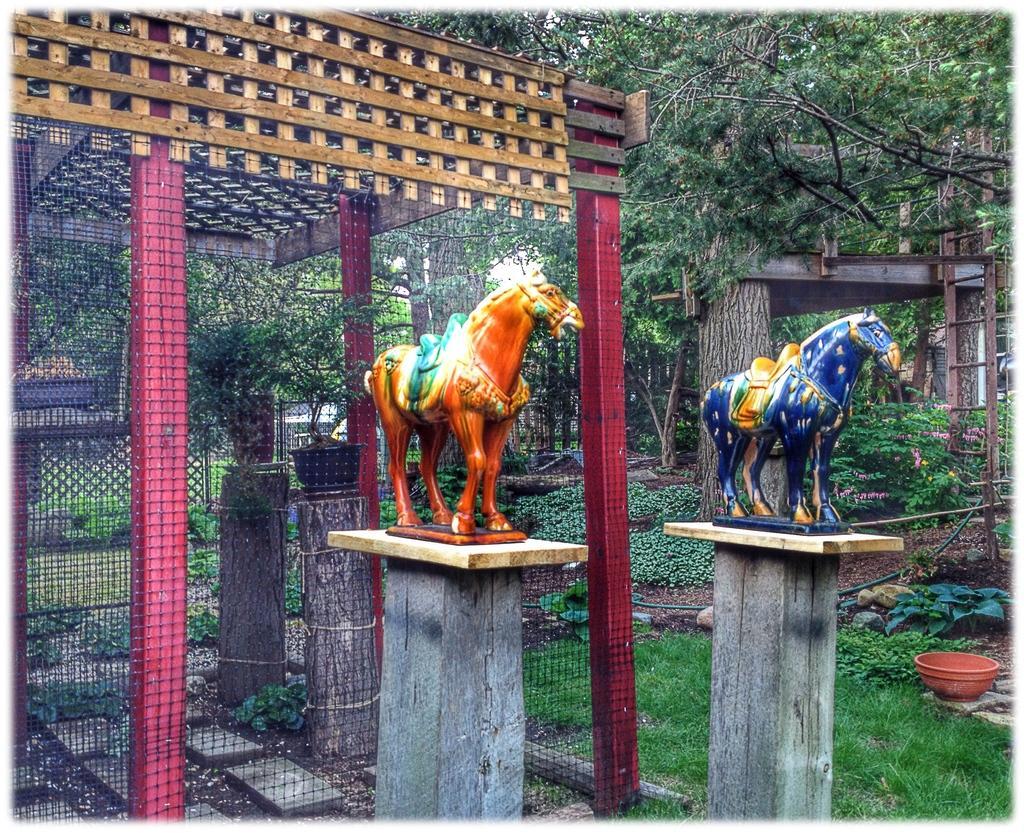In one or two sentences, can you explain what this image depicts? In this picture we can see there are two statues on the poles and behind the statues it is looking like a fence. On the right side of the fence there are trees, a ladder and on the path there is a pot. 